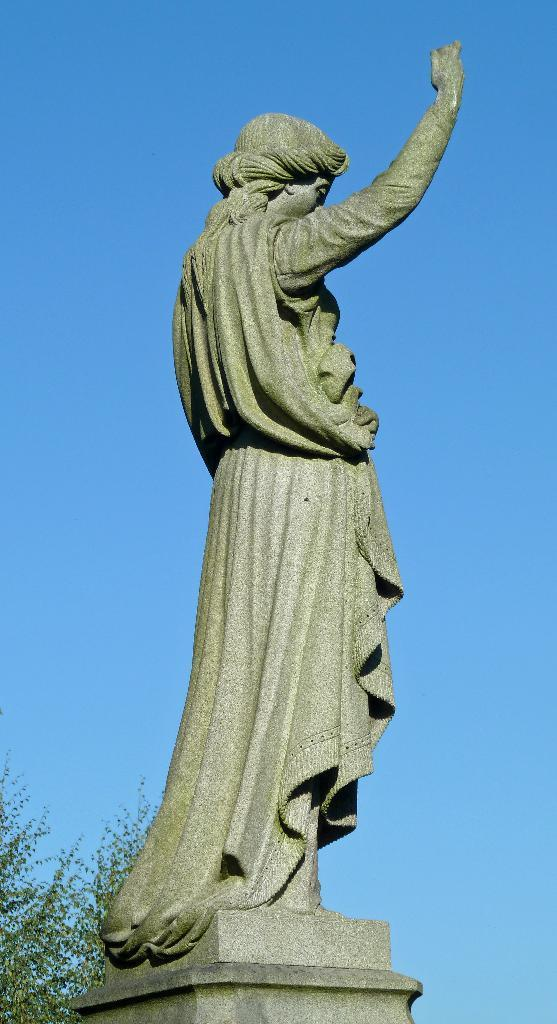What is the main subject in the image? There is a statue of a person in the image. Where is the tree located in the image? The tree is in the bottom left corner of the image. What can be seen in the background of the image? The sky is visible in the background of the image. Is there any blood visible on the statue in the image? No, there is no blood visible on the statue in the image. 